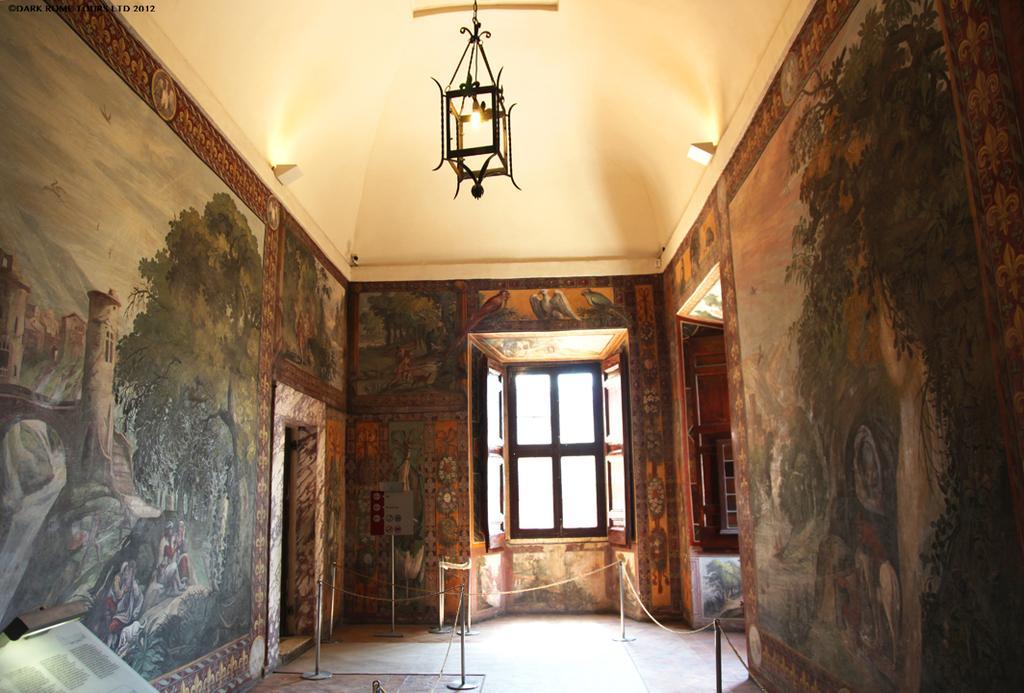Please provide a concise description of this image. In this image, i can see the inside view of a building. There are rope barriers, a board with a pole on the floor and there is a window. I can see the paintings on the wall. In the bottom left corner of the image, there is light and a paper with text. At the top of the image, I can see a lamp hanging to the ceiling. In the top left corner of the image, there is a watermark. 